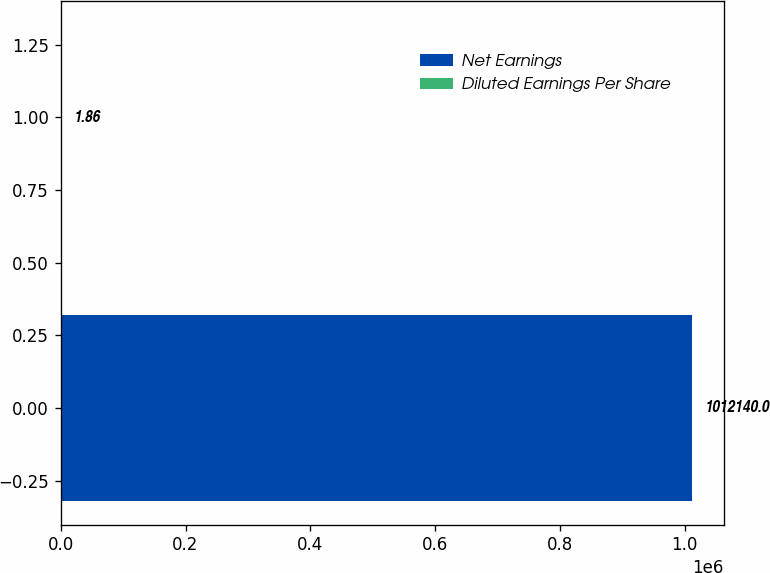Convert chart to OTSL. <chart><loc_0><loc_0><loc_500><loc_500><bar_chart><fcel>Net Earnings<fcel>Diluted Earnings Per Share<nl><fcel>1.01214e+06<fcel>1.86<nl></chart> 